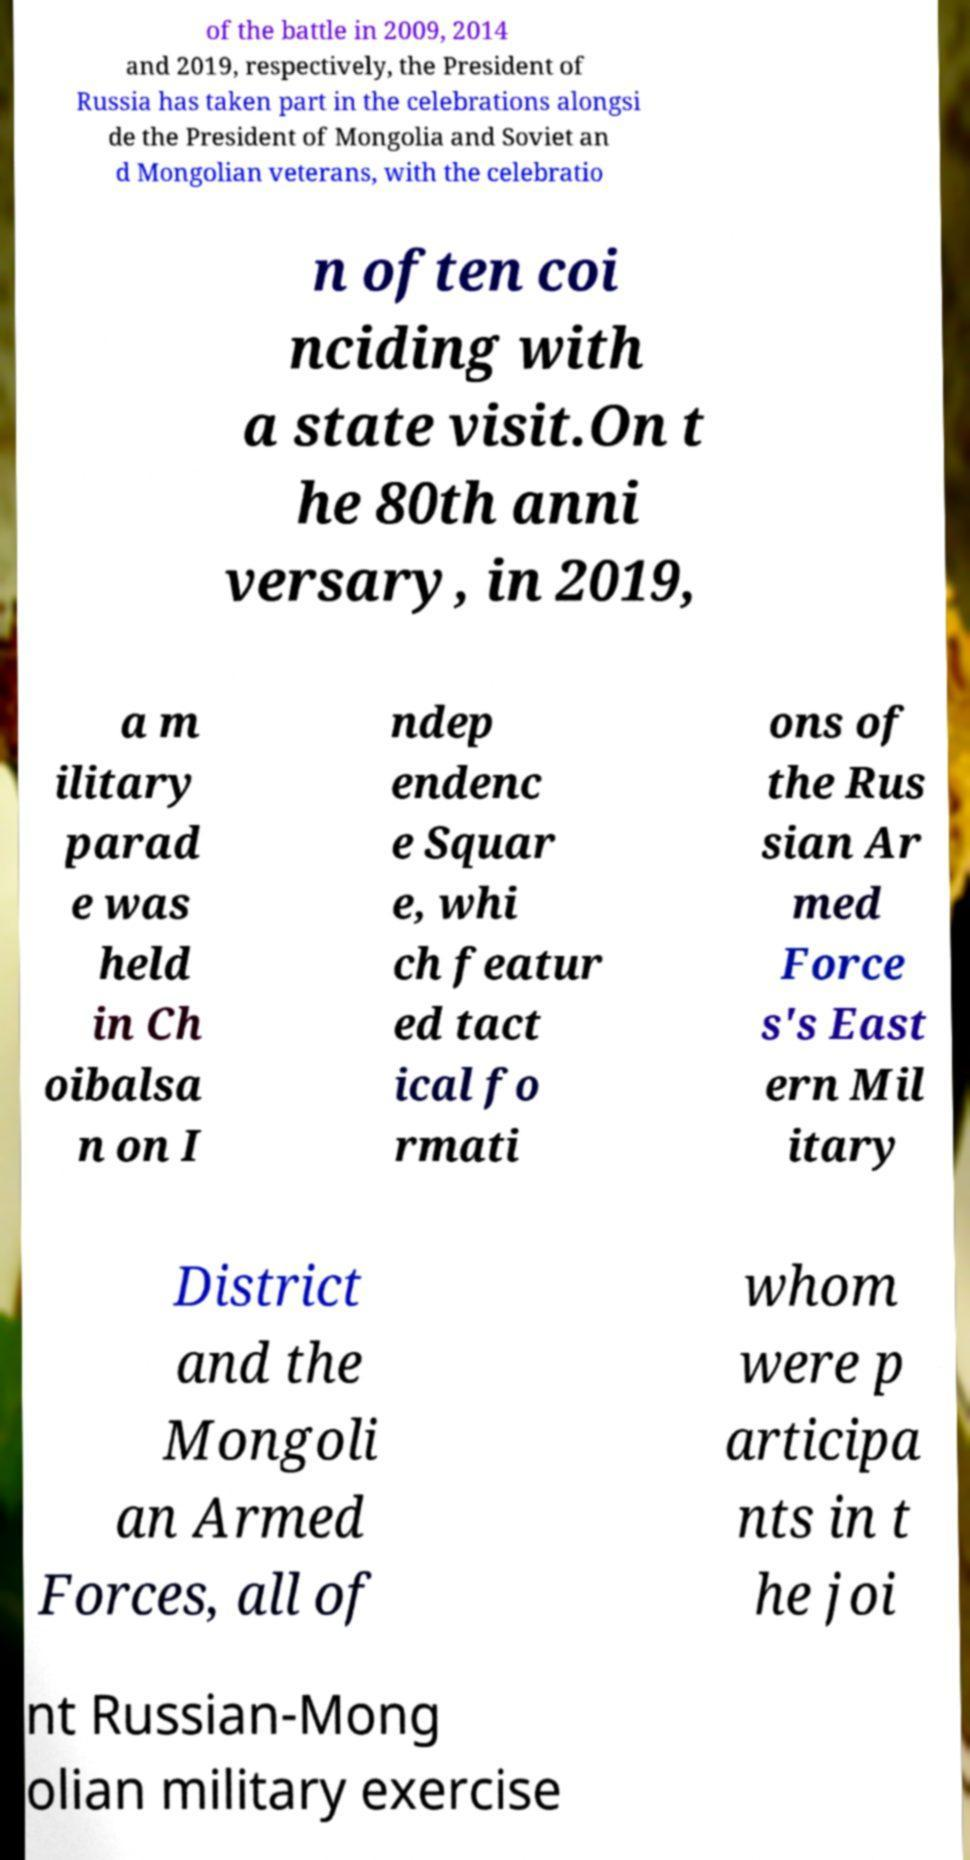Can you read and provide the text displayed in the image?This photo seems to have some interesting text. Can you extract and type it out for me? of the battle in 2009, 2014 and 2019, respectively, the President of Russia has taken part in the celebrations alongsi de the President of Mongolia and Soviet an d Mongolian veterans, with the celebratio n often coi nciding with a state visit.On t he 80th anni versary, in 2019, a m ilitary parad e was held in Ch oibalsa n on I ndep endenc e Squar e, whi ch featur ed tact ical fo rmati ons of the Rus sian Ar med Force s's East ern Mil itary District and the Mongoli an Armed Forces, all of whom were p articipa nts in t he joi nt Russian-Mong olian military exercise 